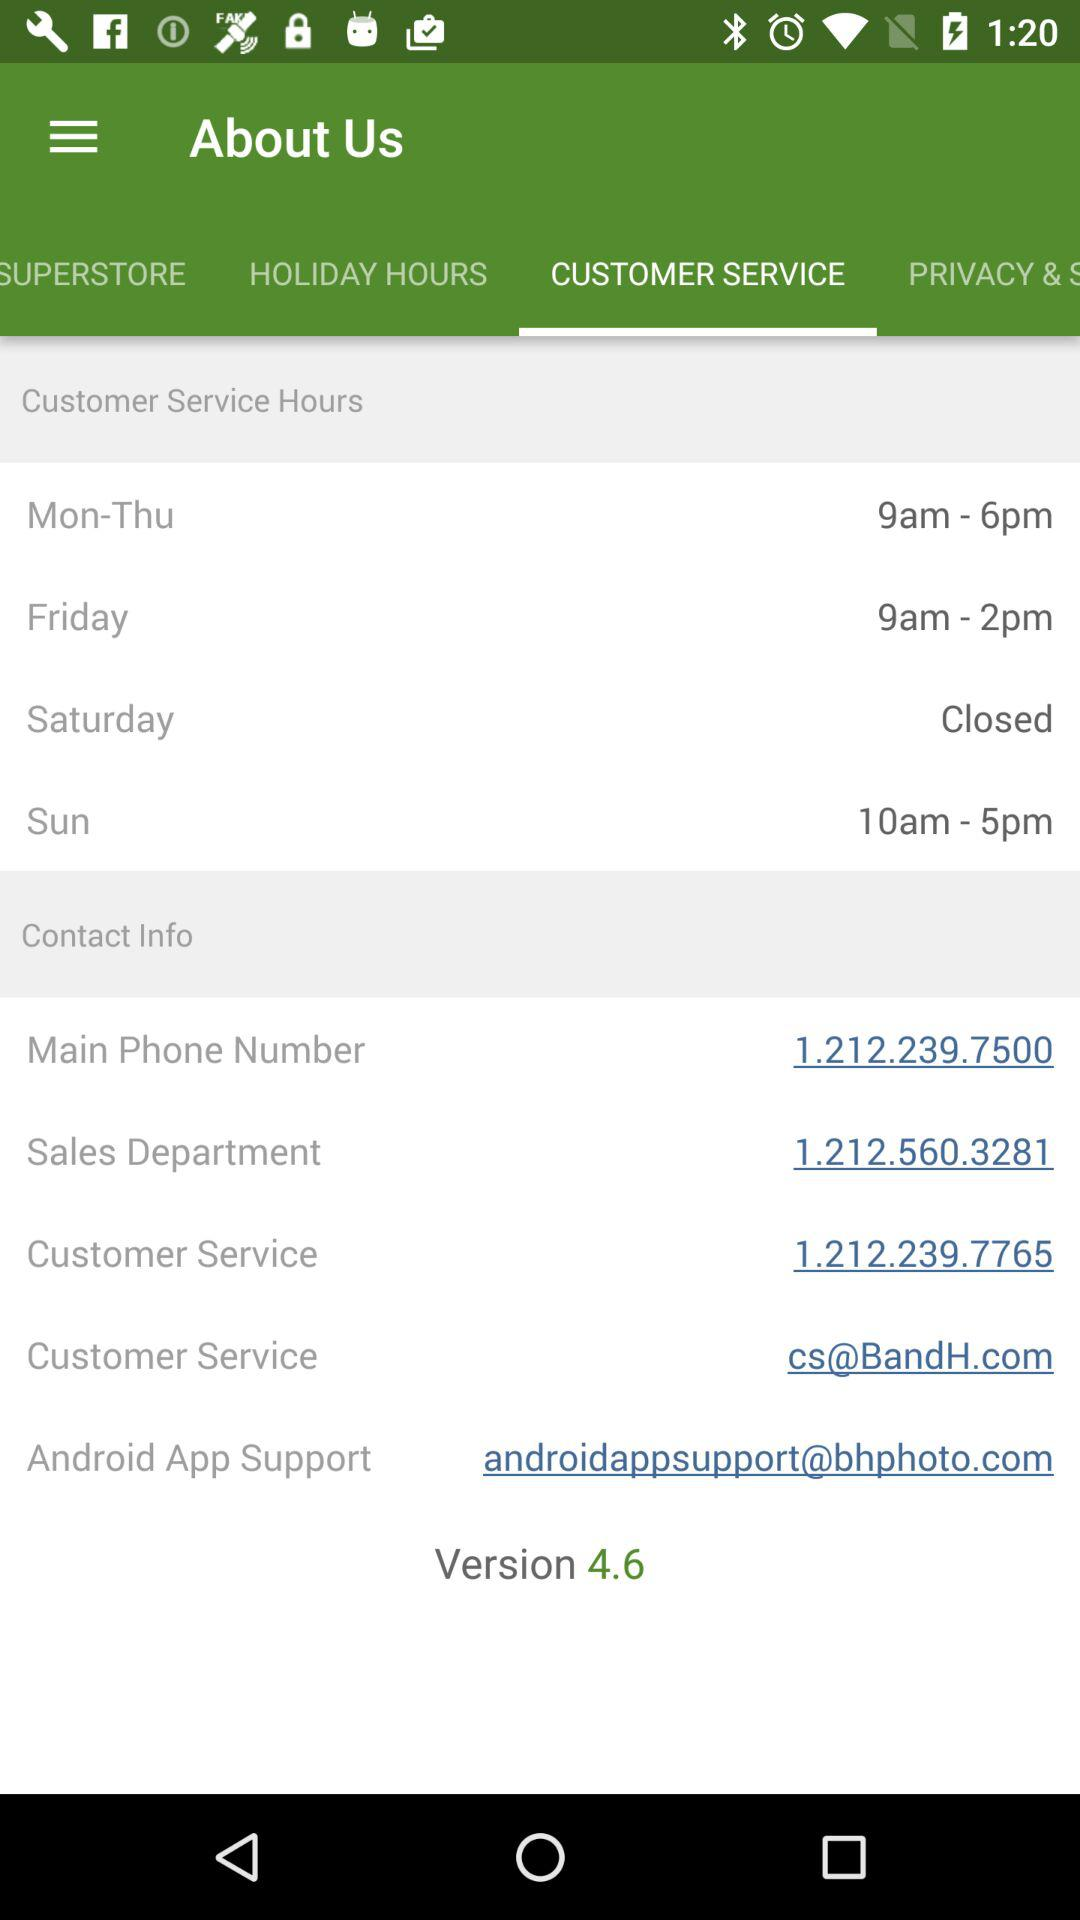What is the email address for customer service? The email address for customer service is cs@BandH.com. 